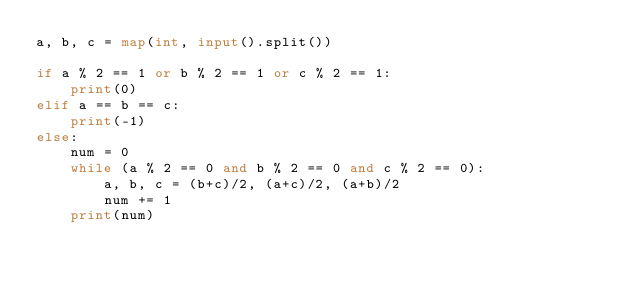Convert code to text. <code><loc_0><loc_0><loc_500><loc_500><_Python_>a, b, c = map(int, input().split())
 
if a % 2 == 1 or b % 2 == 1 or c % 2 == 1:
    print(0)
elif a == b == c:
    print(-1)
else:
    num = 0
    while (a % 2 == 0 and b % 2 == 0 and c % 2 == 0):
        a, b, c = (b+c)/2, (a+c)/2, (a+b)/2
        num += 1
    print(num)</code> 